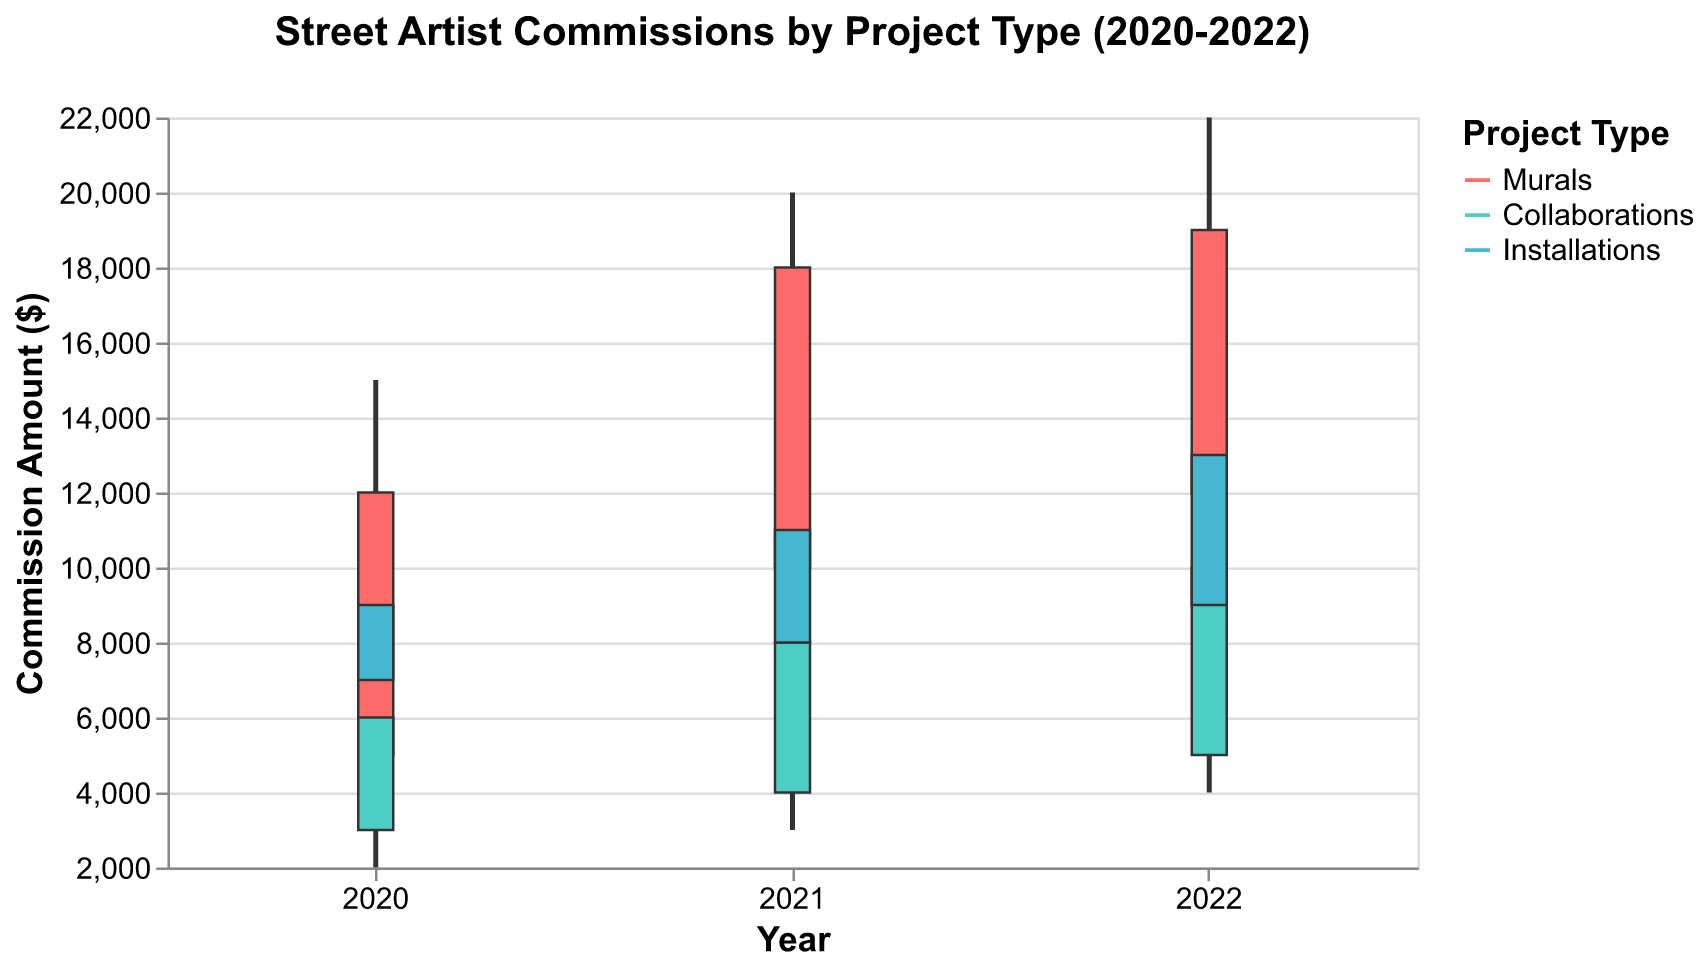What is the title of the figure? The title is located at the top of the figure and provides information about what the chart represents.
Answer: Street Artist Commissions by Project Type (2020-2022) What are the three types of projects shown in the figure? The types of projects are differentiated by color and listed in the legend.
Answer: Murals, Collaborations, Installations In which year did the Murals category see the highest commission between the high and low values? To find this, compare the high values of Murals across the years: 2020, 2021, and 2022.
Answer: 2022 How much did the commission value for Collaborations increase from open to close in 2021? The open value for Collaborations in 2021 is 4000, and the close value is 8000. Subtract the open value from the close value: 8000 - 4000.
Answer: 4000 Which year and project type had the smallest range between the high and low commission values? The range is calculated by subtracting the low value from the high value for each project type in each year, then finding the smallest result.
Answer: Collaborations in 2020 What was the highest commission amount received for Installations in 2022? From the high value of Installations in 2022, which can be found on the y-axis.
Answer: 17000 Between which years did Murals commissions see the most significant increase in closing values? Compare the closing values of Murals for each year: 2020, 2021, and 2022, and find the difference: (2021-2020) and (2022-2021).
Answer: 2020 to 2021 How many project categories showed an increase in the closing value year-over-year from 2020 to 2022? Check the closing values for each project type across the years and see how many show continuous increase from year to year.
Answer: Three (Murals, Collaborations, Installations) In what year and project type was the maximum commission amount the lowest? Compare the high values for each project type in each year to find the minimal maximum.
Answer: Collaborations in 2020 